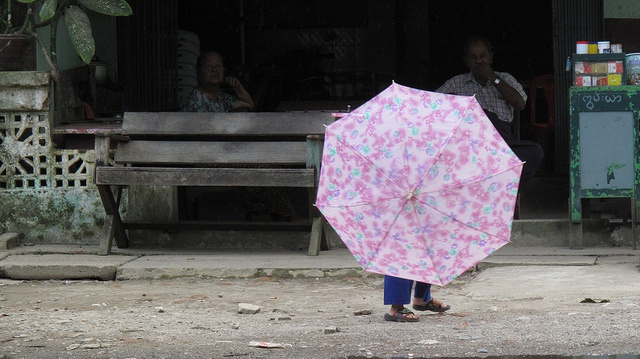Describe the objects in this image and their specific colors. I can see umbrella in black, pink, lavender, and violet tones, bench in black and gray tones, people in black and gray tones, people in black and purple tones, and people in black, navy, gray, and darkgray tones in this image. 